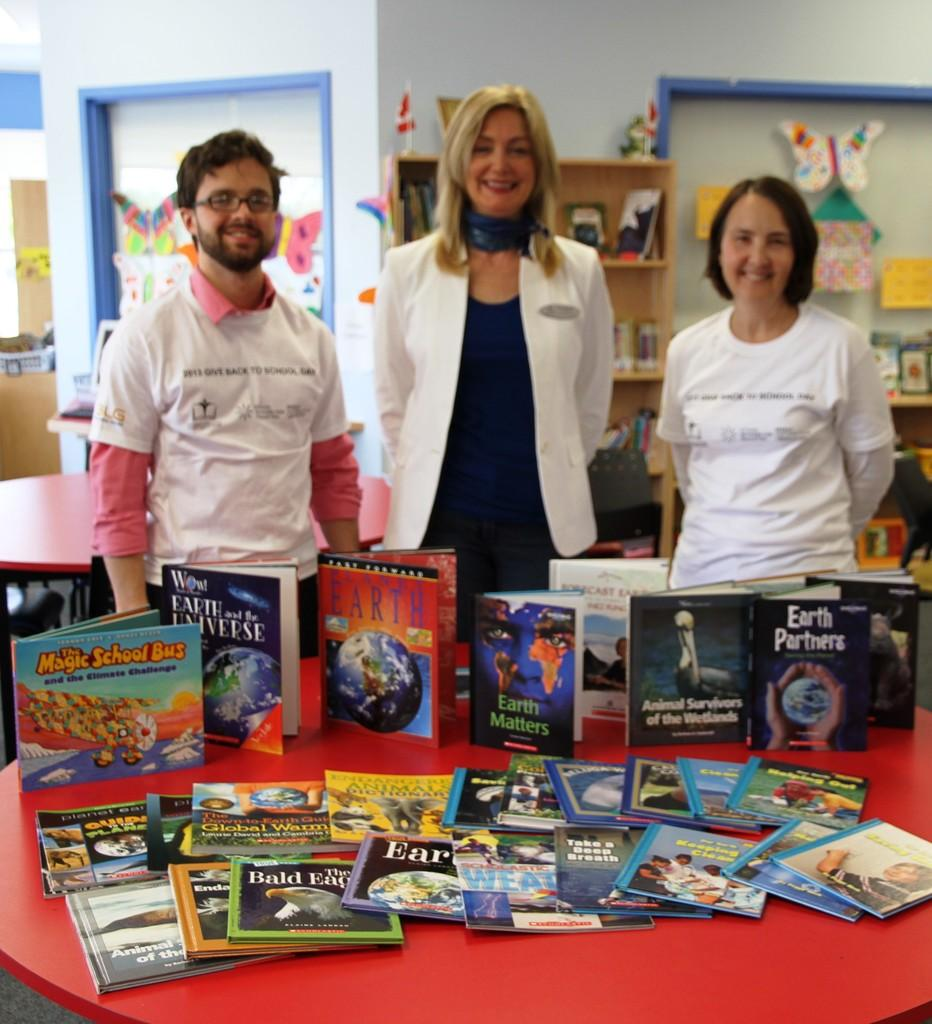<image>
Provide a brief description of the given image. Three people standing behind a display of educational books about the environment. 